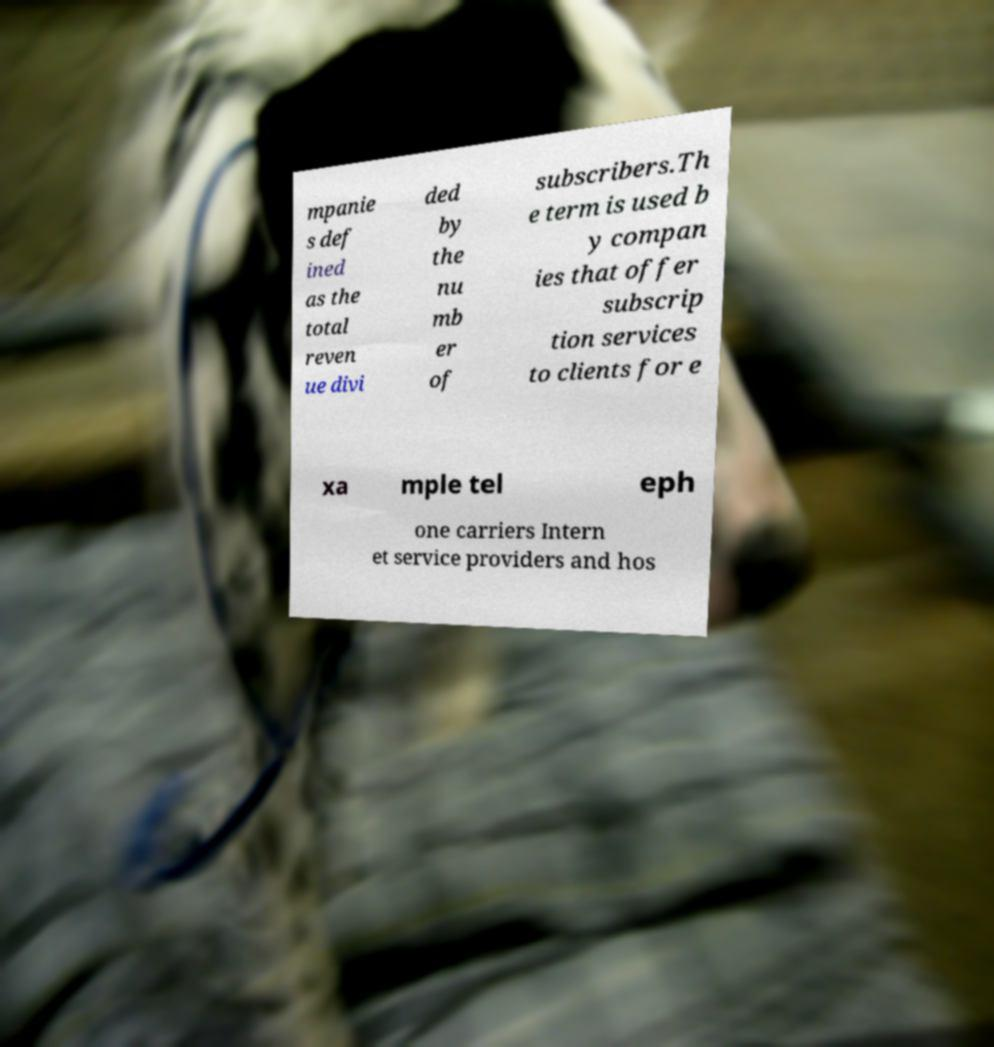Can you read and provide the text displayed in the image?This photo seems to have some interesting text. Can you extract and type it out for me? mpanie s def ined as the total reven ue divi ded by the nu mb er of subscribers.Th e term is used b y compan ies that offer subscrip tion services to clients for e xa mple tel eph one carriers Intern et service providers and hos 